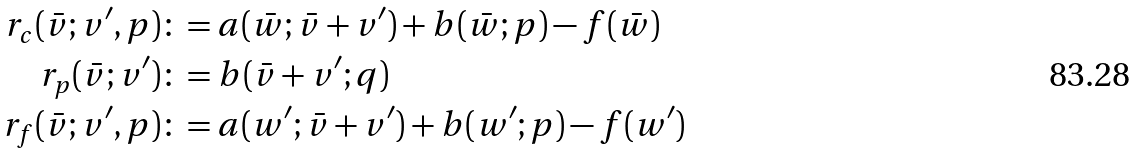<formula> <loc_0><loc_0><loc_500><loc_500>r _ { c } ( \bar { v } ; v ^ { \prime } , p ) & \colon = a ( \bar { w } ; \bar { v } + v ^ { \prime } ) + b ( \bar { w } ; p ) - f ( \bar { w } ) \\ r _ { p } ( \bar { v } ; v ^ { \prime } ) & \colon = b ( \bar { v } + v ^ { \prime } ; q ) \\ r _ { f } ( \bar { v } ; v ^ { \prime } , p ) & \colon = a ( w ^ { \prime } ; \bar { v } + v ^ { \prime } ) + b ( w ^ { \prime } ; p ) - f ( w ^ { \prime } )</formula> 